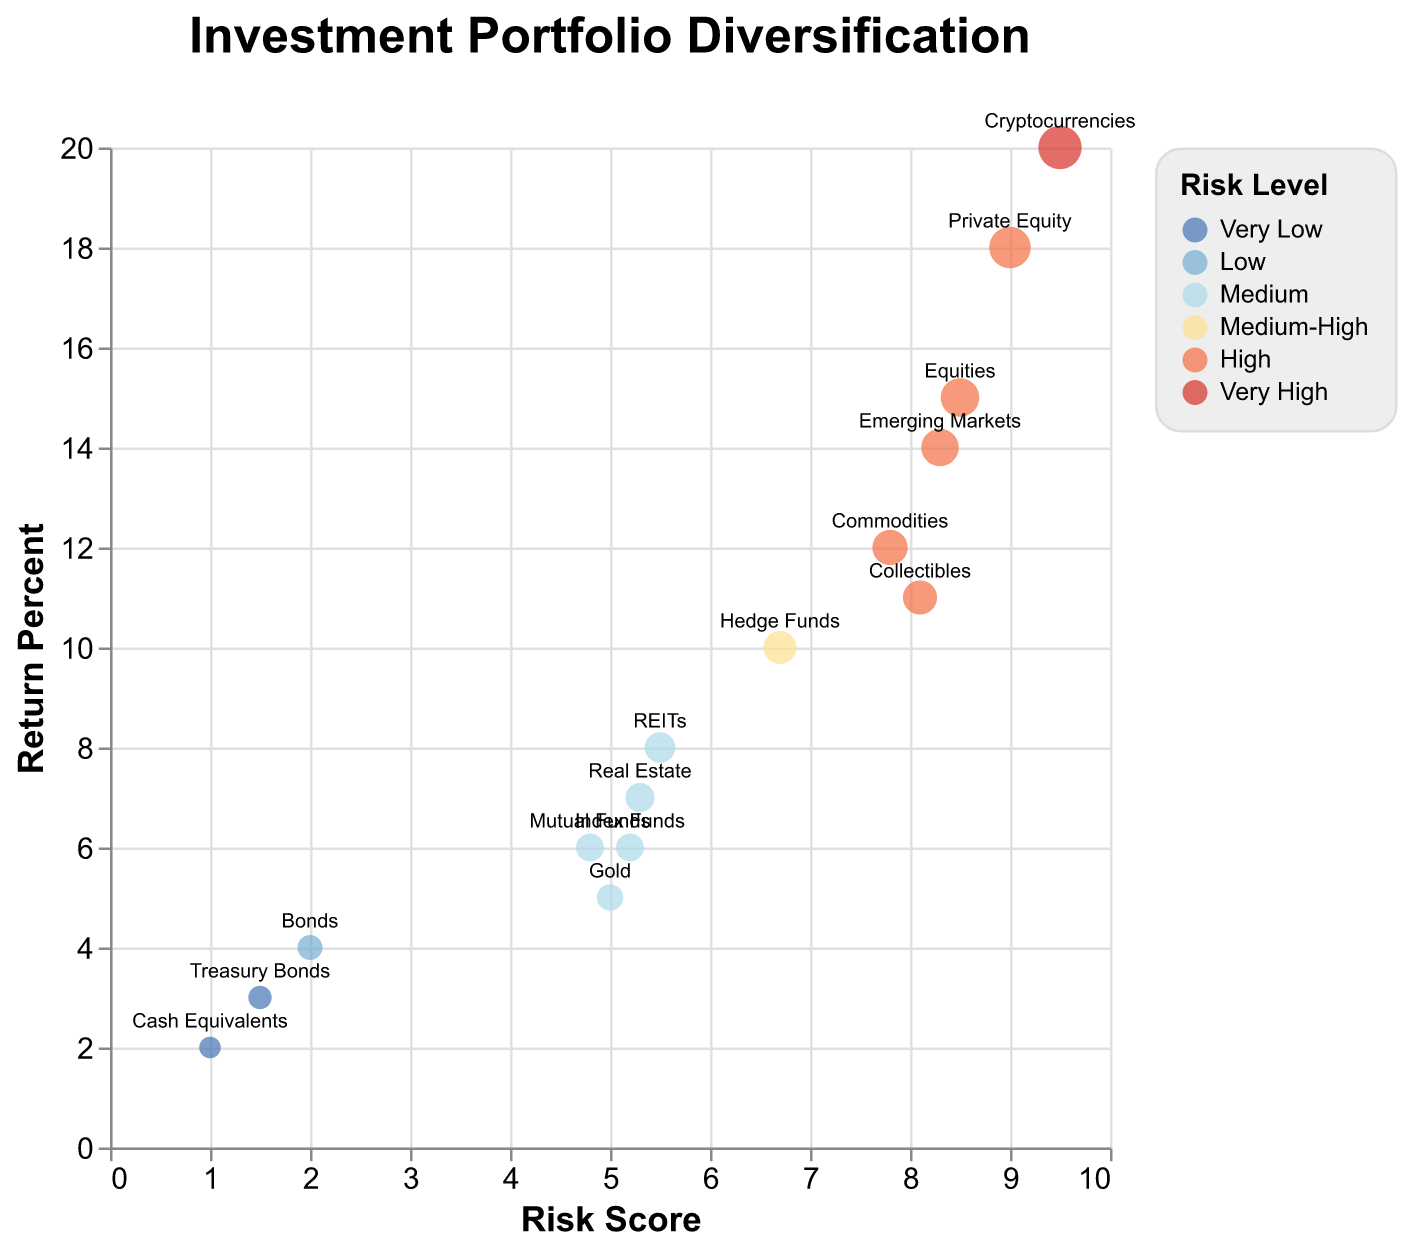What is the title of the figure? The title of a figure is typically displayed at the top of the chart, and in this case, it is "Investment Portfolio Diversification".
Answer: Investment Portfolio Diversification How many asset classes have a very high-risk level? The color legend indicates the categories for risk levels, and the corresponding data points can be identified by the colors. Looking at the plot, we see that only Cryptocurrencies have a "Very High" risk level.
Answer: 1 Which asset class has the highest return percent? To determine this, locate the data point with the highest y-axis value (Return Percent). Cryptocurrencies have the highest return percent at 20%.
Answer: Cryptocurrencies Which asset class has the lowest risk score, and what is that score? Locate the data point with the lowest x-axis value (Risk Score). Cash Equivalents have the lowest risk score of 1.0.
Answer: Cash Equivalents, 1.0 What is the average return percent for the medium-risk level asset classes? Identify all the medium-risk level asset classes (Real Estate, Gold, REITs, Index Funds) and then find the average of their return percents: (7 + 5 + 8 + 6)/4 = 6.5.
Answer: 6.5 Compare the return percent of Equities and Commodities. Which one is higher, and by how much? Identify the return percents for Equities (15%) and Commodities (12%). The return percent of Equities is higher by 3%.
Answer: Equities, by 3% What is the relationship between risk score and return percent in this data? Observe the general trend in the scatter plot. As risk score increases along the x-axis, return percent generally increases along the y-axis, indicating a positive correlation.
Answer: Positive correlation Which asset class has a similar risk score to Gold but a higher return percent? Gold has a risk score of 5.0 with a return percent of 5.0. Look for another asset class with a similar risk score but a higher return percent. Real Estate has a risk score of 5.3 and a return percent of 7.
Answer: Real Estate What is the combined return percent of all low and very low-risk level assets? Identify low (Bonds) and very low-risk level assets (Cash Equivalents, Treasury Bonds) and sum their return percents: 4 + 2 + 3 = 9.
Answer: 9 How does the return percent of Private Equity compare with Hedge Funds? Locate the return percents of Private Equity (18%) and Hedge Funds (10%). Private Equity has a significantly higher return percent compared to Hedge Funds by 8%.
Answer: Private Equity, by 8% 